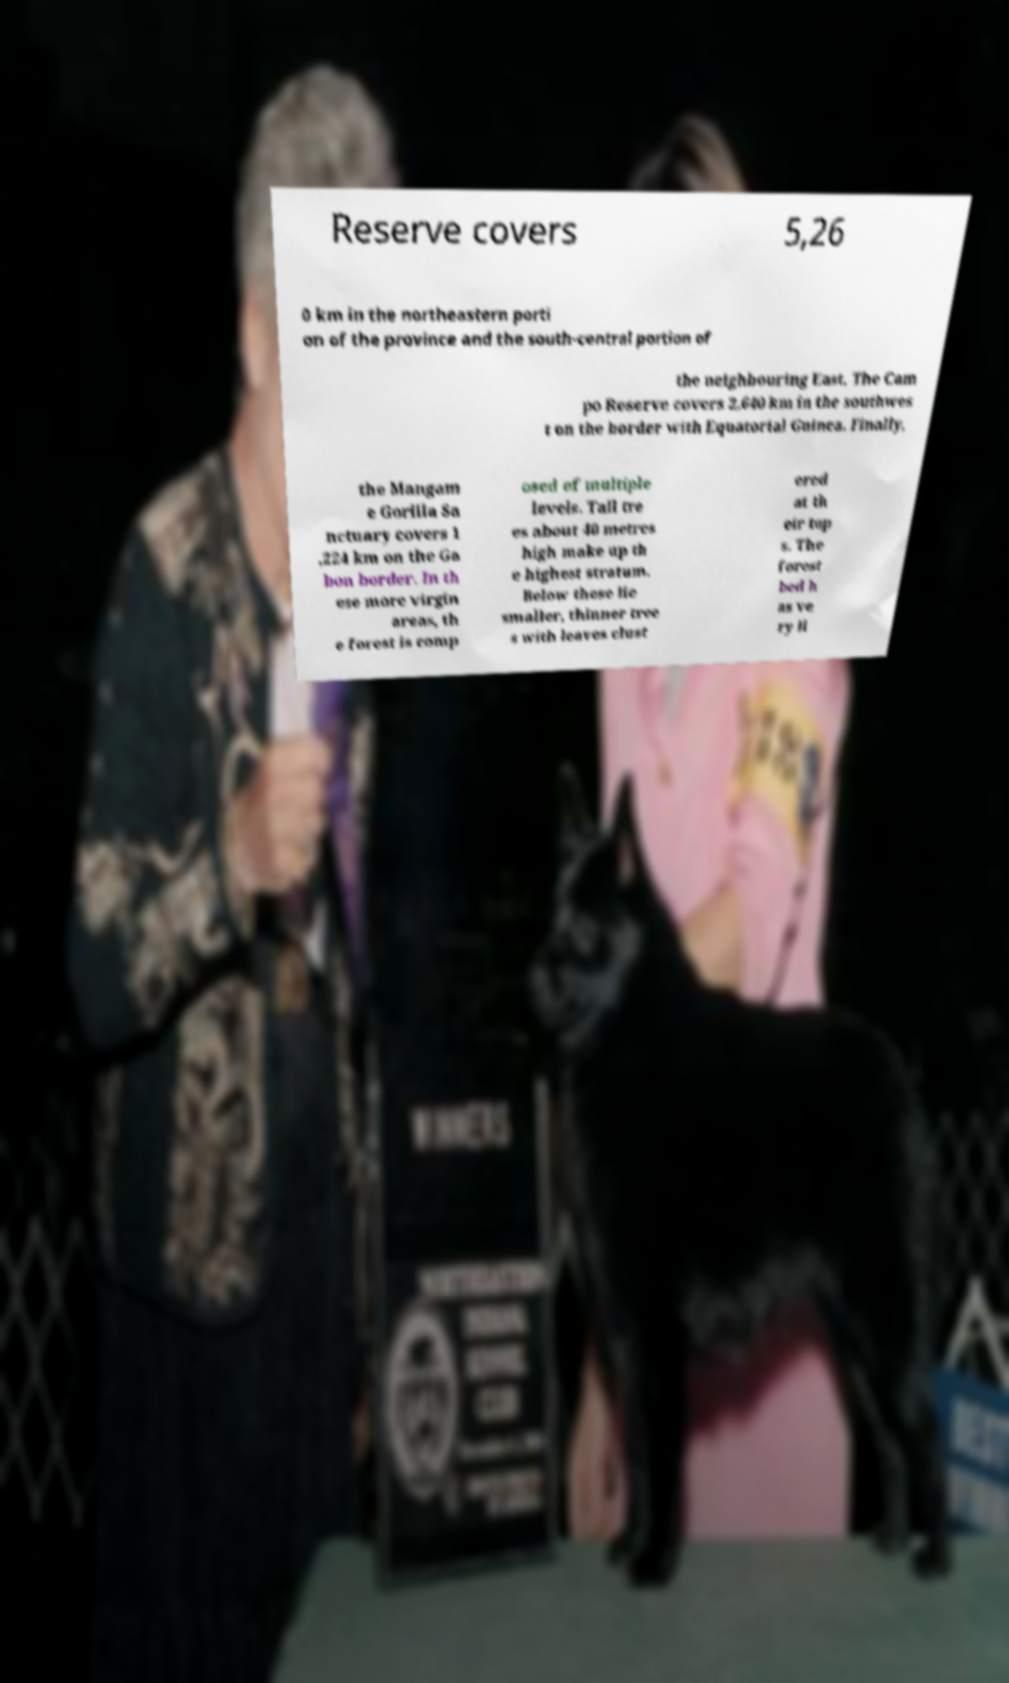Can you read and provide the text displayed in the image?This photo seems to have some interesting text. Can you extract and type it out for me? Reserve covers 5,26 0 km in the northeastern porti on of the province and the south-central portion of the neighbouring East. The Cam po Reserve covers 2,640 km in the southwes t on the border with Equatorial Guinea. Finally, the Mangam e Gorilla Sa nctuary covers 1 ,224 km on the Ga bon border. In th ese more virgin areas, th e forest is comp osed of multiple levels. Tall tre es about 40 metres high make up th e highest stratum. Below these lie smaller, thinner tree s with leaves clust ered at th eir top s. The forest bed h as ve ry li 